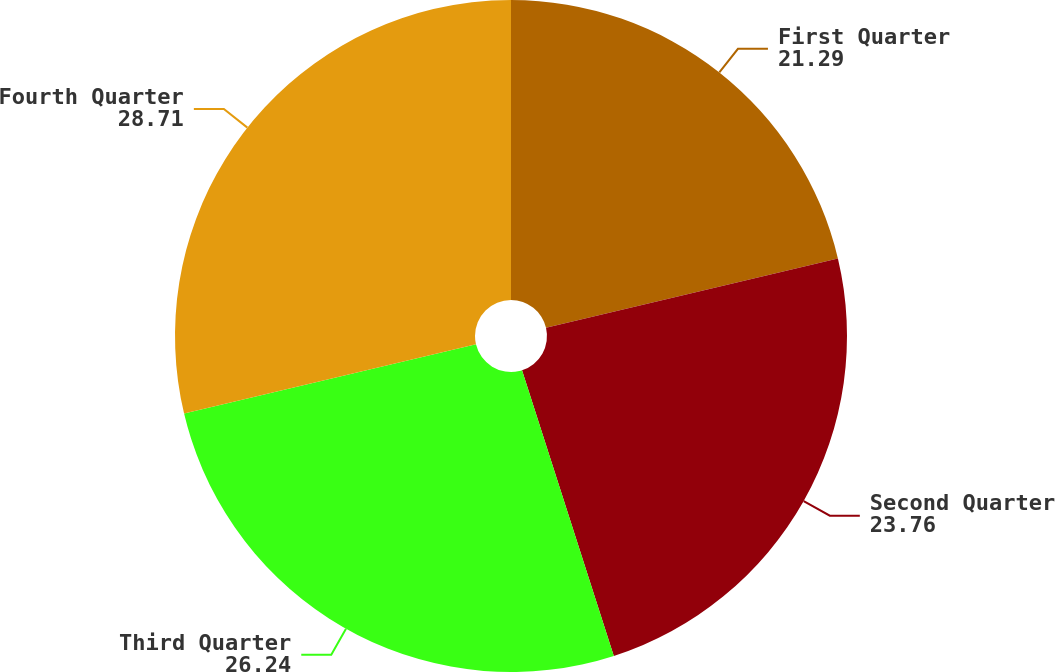Convert chart to OTSL. <chart><loc_0><loc_0><loc_500><loc_500><pie_chart><fcel>First Quarter<fcel>Second Quarter<fcel>Third Quarter<fcel>Fourth Quarter<nl><fcel>21.29%<fcel>23.76%<fcel>26.24%<fcel>28.71%<nl></chart> 